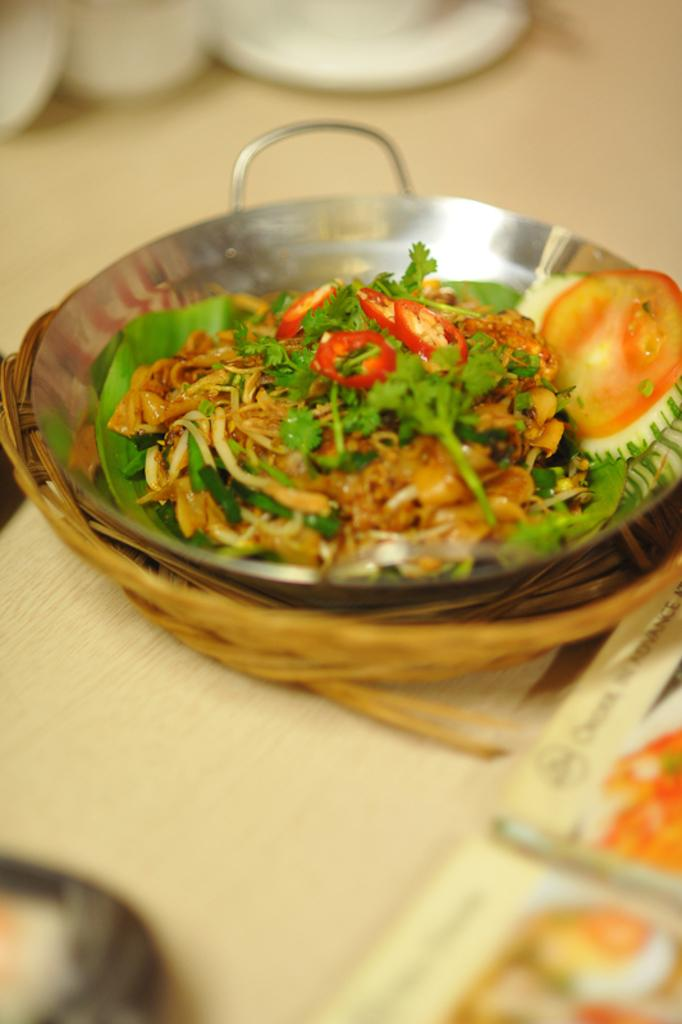What type of container holds the food in the image? The food is in a steel bowl. Where is the steel bowl located? The bowl is in a basket. What is the basket resting on? The basket is on a wooden board. What colors can be seen in the food? The food has colors including white, brown, green, and red. What type of soda is being served in the image? There is no soda present in the image; it features food in a steel bowl, located in a basket on a wooden board. Who is the representative of the food in the image? There is no representative present in the image; it simply shows food in a steel bowl, located in a basket on a wooden board. 